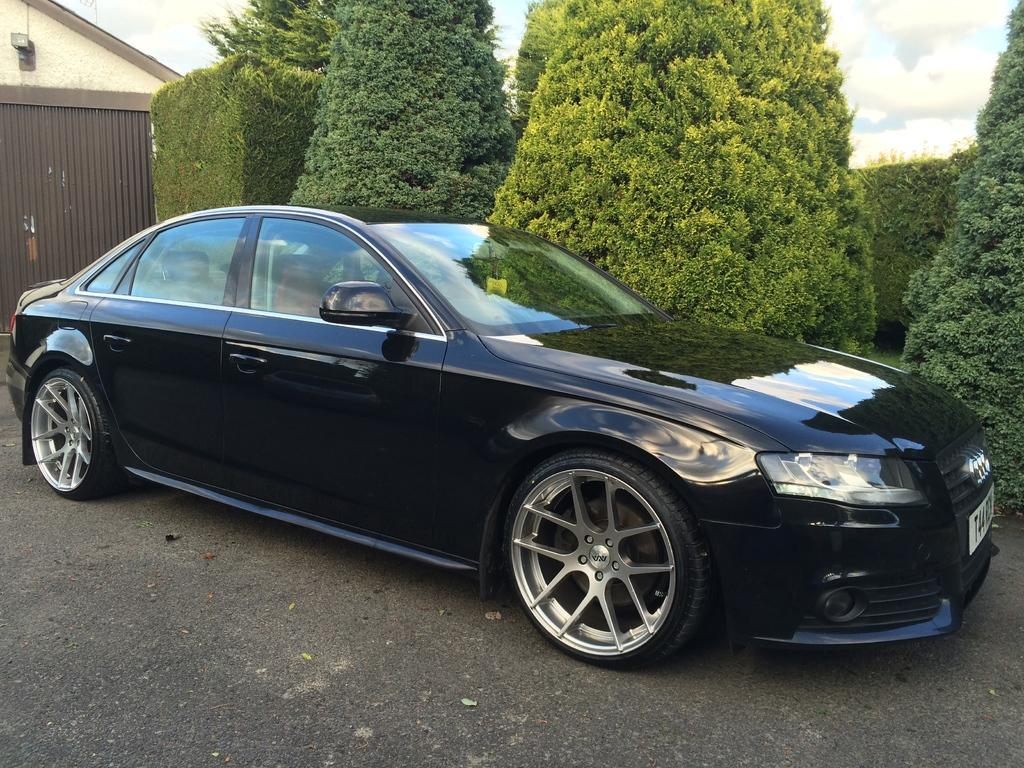What color is the car in the image? The car in the image is black. Where is the car located in the image? The car is on the ground. What can be seen in the background of the image? There is a house, trees, and the sky visible in the background of the image. Is there a scarecrow standing next to the car in the image? No, there is no scarecrow present in the image. What type of plant is growing near the car in the image? There is no plant visible near the car in the image. 